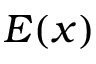Convert formula to latex. <formula><loc_0><loc_0><loc_500><loc_500>E ( x )</formula> 